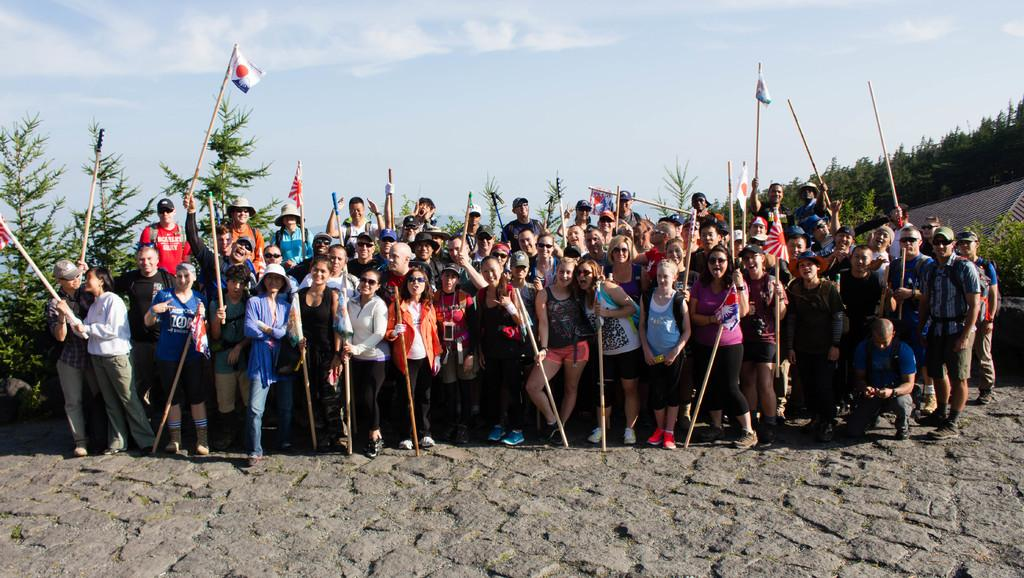What is happening in the middle of the image? There are people standing in the middle of the image. What are the people holding in their hands? The people are holding sticks and flags. What can be seen in the background of the image? There are trees visible in the background. What is visible at the top of the image? There are clouds and sky at the top of the image. Can you tell me how many goats are present in the image? There are no goats present in the image. What type of connection can be seen between the people in the image? There is no specific connection between the people visible in the image. 